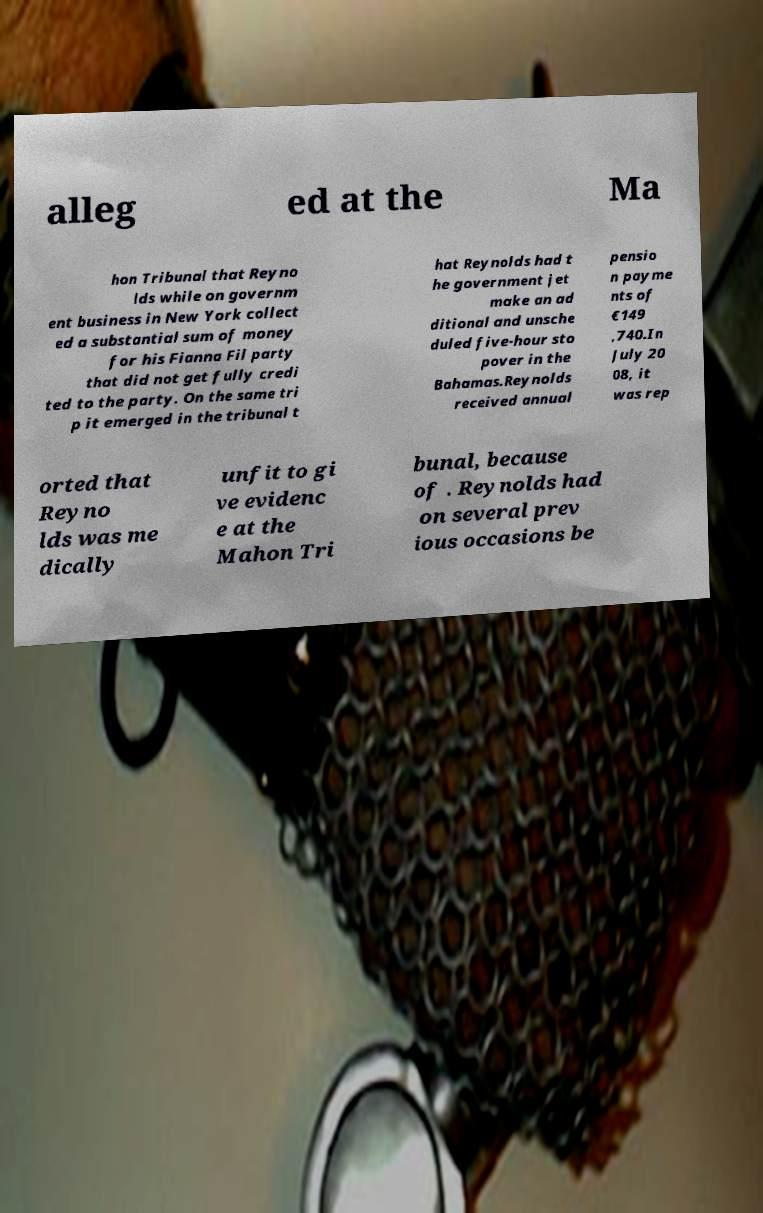I need the written content from this picture converted into text. Can you do that? alleg ed at the Ma hon Tribunal that Reyno lds while on governm ent business in New York collect ed a substantial sum of money for his Fianna Fil party that did not get fully credi ted to the party. On the same tri p it emerged in the tribunal t hat Reynolds had t he government jet make an ad ditional and unsche duled five-hour sto pover in the Bahamas.Reynolds received annual pensio n payme nts of €149 ,740.In July 20 08, it was rep orted that Reyno lds was me dically unfit to gi ve evidenc e at the Mahon Tri bunal, because of . Reynolds had on several prev ious occasions be 